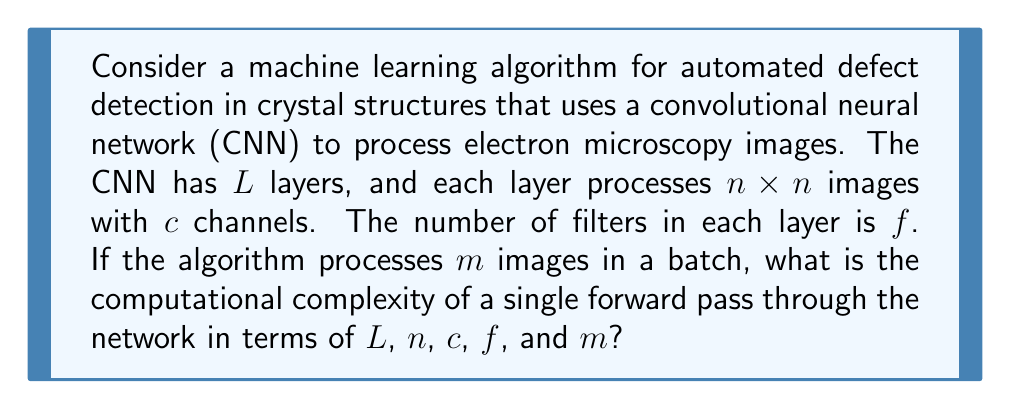Solve this math problem. To determine the computational complexity, we need to analyze the operations performed in each layer of the CNN:

1. For each convolutional layer:
   - Number of operations per filter: $O(n^2c)$
   - Number of filters: $f$
   - Total operations per layer: $O(n^2cf)$

2. We have $L$ layers, so the total operations for one image: $O(Ln^2cf)$

3. For a batch of $m$ images:
   - Total operations: $O(mLn^2cf)$

The computational complexity is dominated by the convolutional operations, as other operations (like pooling and activation functions) typically have lower complexity.

Key assumptions:
- The image size ($n \times n$) and number of channels ($c$) remain constant throughout the network. In practice, these may change between layers, but this simplification allows us to express the complexity in terms of the given variables.
- The number of filters ($f$) is assumed to be the same for each layer. In real CNNs, this might vary, but we use a constant $f$ for simplicity.

This analysis provides an upper bound on the computational complexity, which is useful for understanding how the algorithm's performance scales with different parameters. In the context of electron microscopy and defect detection in crystal structures, this complexity analysis helps in estimating the computational resources required for processing large datasets of high-resolution images.
Answer: The computational complexity of a single forward pass through the network for a batch of $m$ images is $O(mLn^2cf)$. 